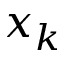<formula> <loc_0><loc_0><loc_500><loc_500>x _ { k }</formula> 